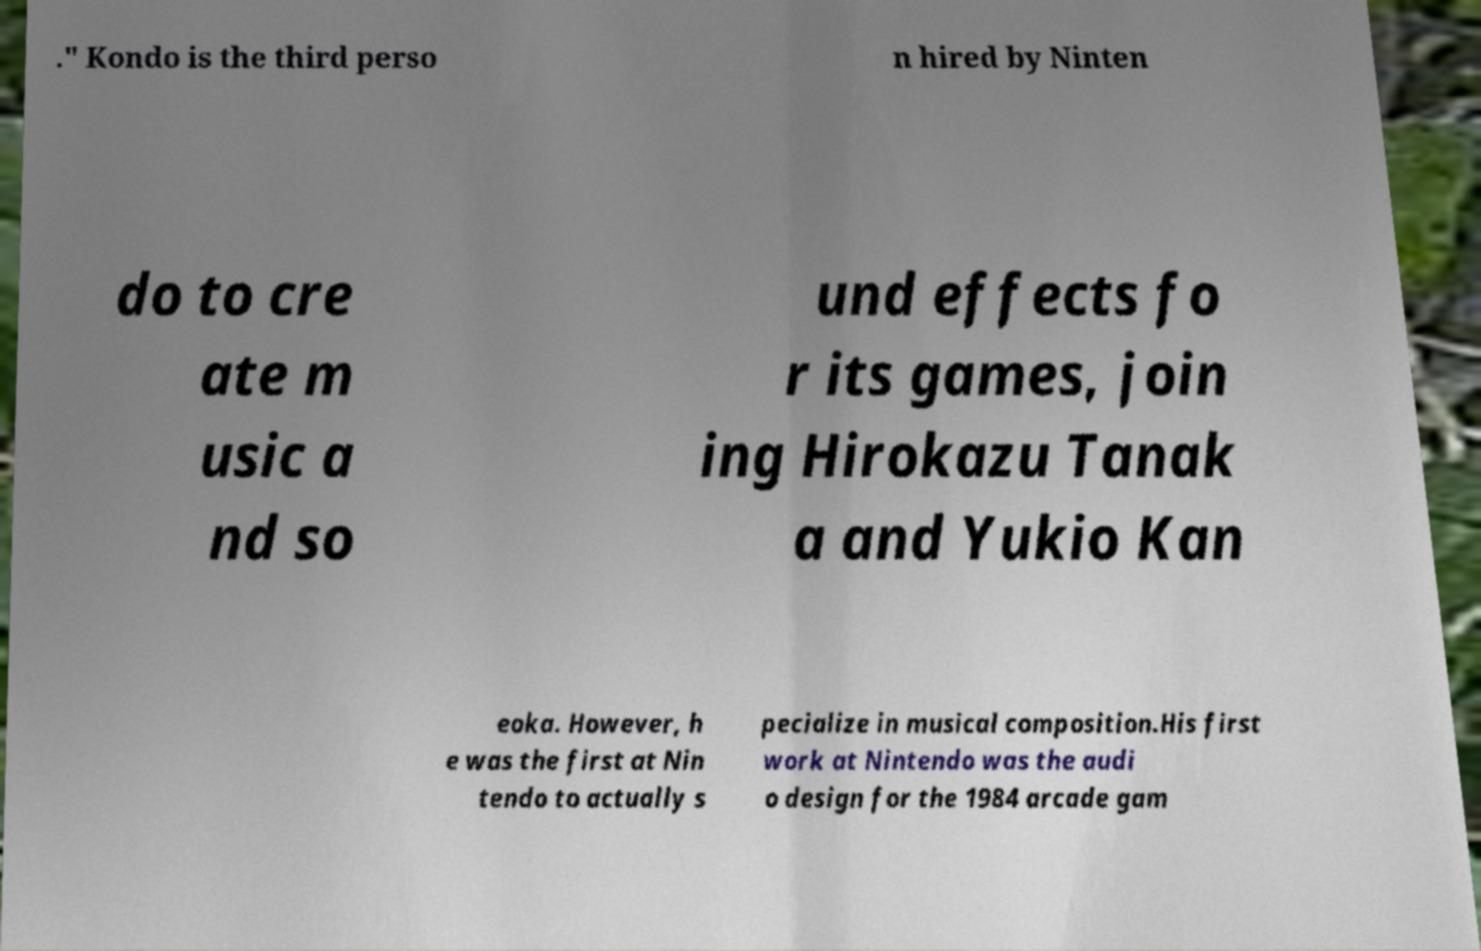Can you read and provide the text displayed in the image?This photo seems to have some interesting text. Can you extract and type it out for me? ." Kondo is the third perso n hired by Ninten do to cre ate m usic a nd so und effects fo r its games, join ing Hirokazu Tanak a and Yukio Kan eoka. However, h e was the first at Nin tendo to actually s pecialize in musical composition.His first work at Nintendo was the audi o design for the 1984 arcade gam 